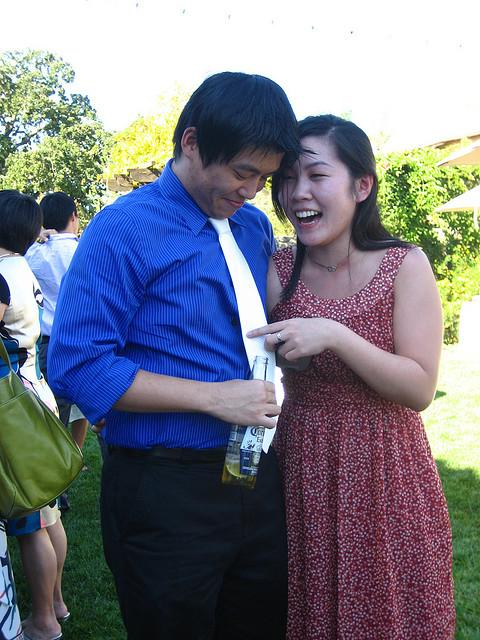How are the two people related? Please explain your reasoning. lovers. The people are a couple. 